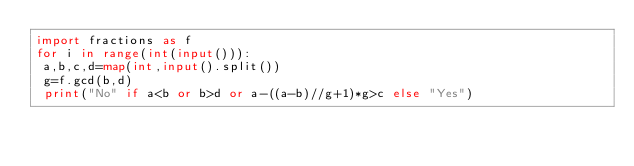Convert code to text. <code><loc_0><loc_0><loc_500><loc_500><_Python_>import fractions as f
for i in range(int(input())):
 a,b,c,d=map(int,input().split())
 g=f.gcd(b,d)
 print("No" if a<b or b>d or a-((a-b)//g+1)*g>c else "Yes")</code> 